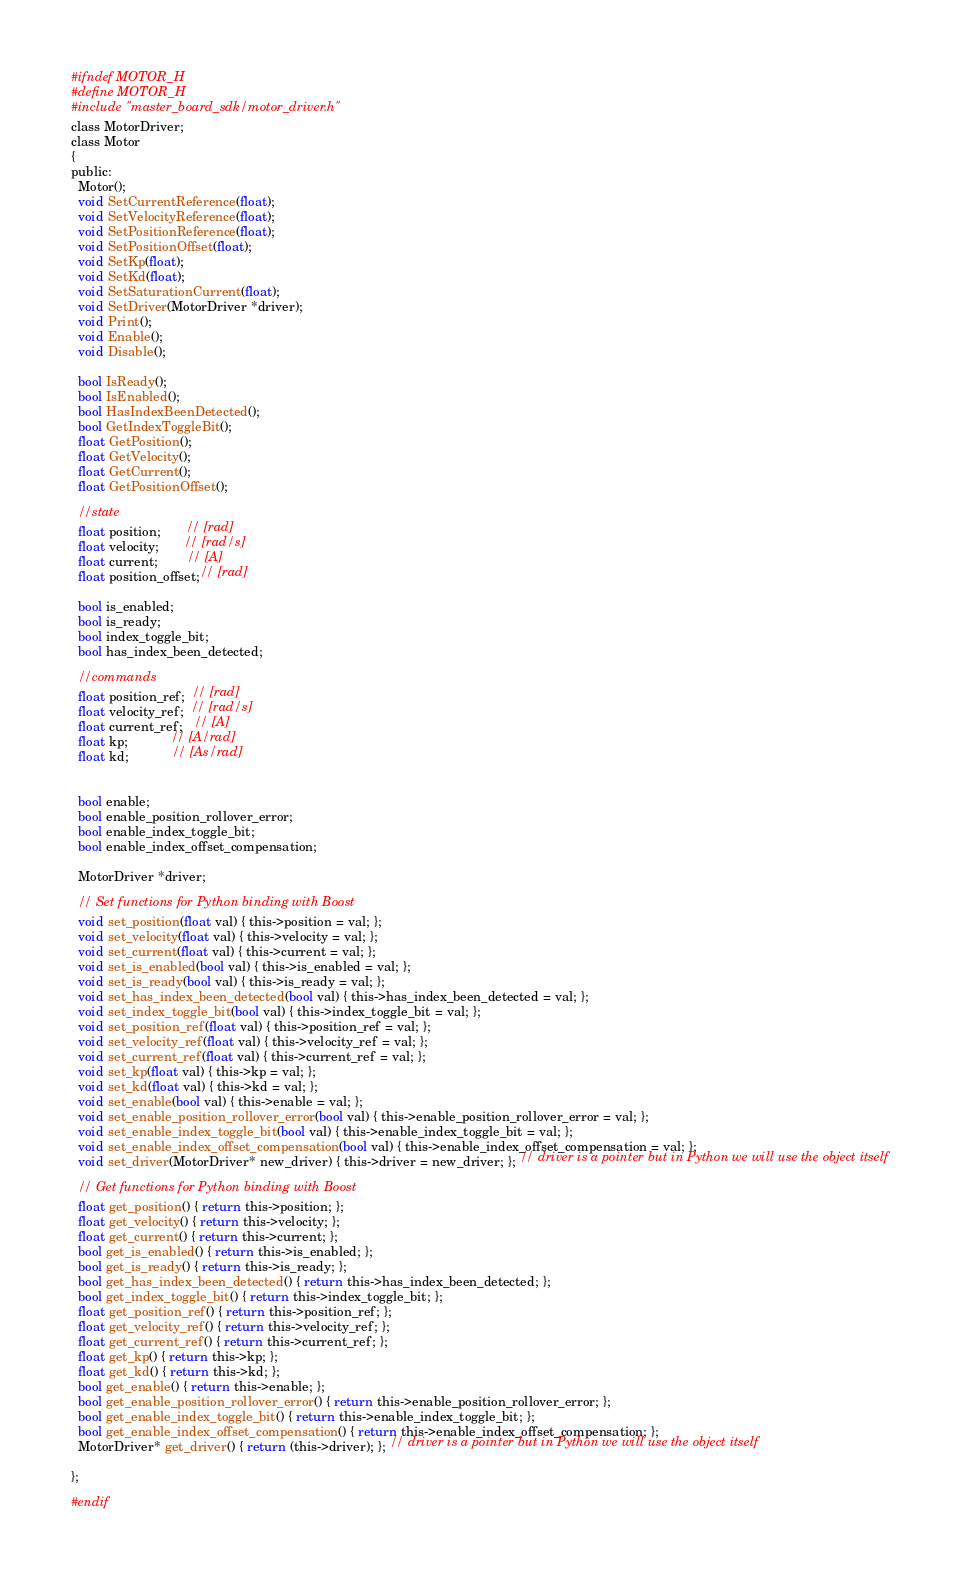Convert code to text. <code><loc_0><loc_0><loc_500><loc_500><_C_>#ifndef MOTOR_H
#define MOTOR_H
#include "master_board_sdk/motor_driver.h"
class MotorDriver;
class Motor
{
public:
  Motor();
  void SetCurrentReference(float);
  void SetVelocityReference(float);
  void SetPositionReference(float);
  void SetPositionOffset(float);
  void SetKp(float);
  void SetKd(float);
  void SetSaturationCurrent(float);
  void SetDriver(MotorDriver *driver);
  void Print();
  void Enable();
  void Disable();

  bool IsReady();
  bool IsEnabled();
  bool HasIndexBeenDetected();
  bool GetIndexToggleBit();
  float GetPosition();
  float GetVelocity();
  float GetCurrent();
  float GetPositionOffset();

  //state
  float position;       // [rad]
  float velocity;       // [rad/s]
  float current;        // [A]
  float position_offset;// [rad]

  bool is_enabled;
  bool is_ready;
  bool index_toggle_bit;
  bool has_index_been_detected;

  //commands
  float position_ref;  // [rad]
  float velocity_ref;  // [rad/s]
  float current_ref;   // [A]
  float kp;            // [A/rad]
  float kd;            // [As/rad]


  bool enable;
  bool enable_position_rollover_error;
  bool enable_index_toggle_bit;
  bool enable_index_offset_compensation;

  MotorDriver *driver;

  // Set functions for Python binding with Boost
  void set_position(float val) { this->position = val; };
  void set_velocity(float val) { this->velocity = val; };
  void set_current(float val) { this->current = val; };
  void set_is_enabled(bool val) { this->is_enabled = val; };
  void set_is_ready(bool val) { this->is_ready = val; };
  void set_has_index_been_detected(bool val) { this->has_index_been_detected = val; };
  void set_index_toggle_bit(bool val) { this->index_toggle_bit = val; };
  void set_position_ref(float val) { this->position_ref = val; };
  void set_velocity_ref(float val) { this->velocity_ref = val; };
  void set_current_ref(float val) { this->current_ref = val; };
  void set_kp(float val) { this->kp = val; };
  void set_kd(float val) { this->kd = val; };
  void set_enable(bool val) { this->enable = val; };
  void set_enable_position_rollover_error(bool val) { this->enable_position_rollover_error = val; };
  void set_enable_index_toggle_bit(bool val) { this->enable_index_toggle_bit = val; };
  void set_enable_index_offset_compensation(bool val) { this->enable_index_offset_compensation = val; };
  void set_driver(MotorDriver* new_driver) { this->driver = new_driver; }; // driver is a pointer but in Python we will use the object itself

  // Get functions for Python binding with Boost
  float get_position() { return this->position; };
  float get_velocity() { return this->velocity; };
  float get_current() { return this->current; };
  bool get_is_enabled() { return this->is_enabled; };
  bool get_is_ready() { return this->is_ready; };
  bool get_has_index_been_detected() { return this->has_index_been_detected; };
  bool get_index_toggle_bit() { return this->index_toggle_bit; };
  float get_position_ref() { return this->position_ref; };
  float get_velocity_ref() { return this->velocity_ref; };
  float get_current_ref() { return this->current_ref; };
  float get_kp() { return this->kp; };
  float get_kd() { return this->kd; };
  bool get_enable() { return this->enable; };
  bool get_enable_position_rollover_error() { return this->enable_position_rollover_error; };
  bool get_enable_index_toggle_bit() { return this->enable_index_toggle_bit; };
  bool get_enable_index_offset_compensation() { return this->enable_index_offset_compensation; };
  MotorDriver* get_driver() { return (this->driver); }; // driver is a pointer but in Python we will use the object itself
  
};

#endif</code> 